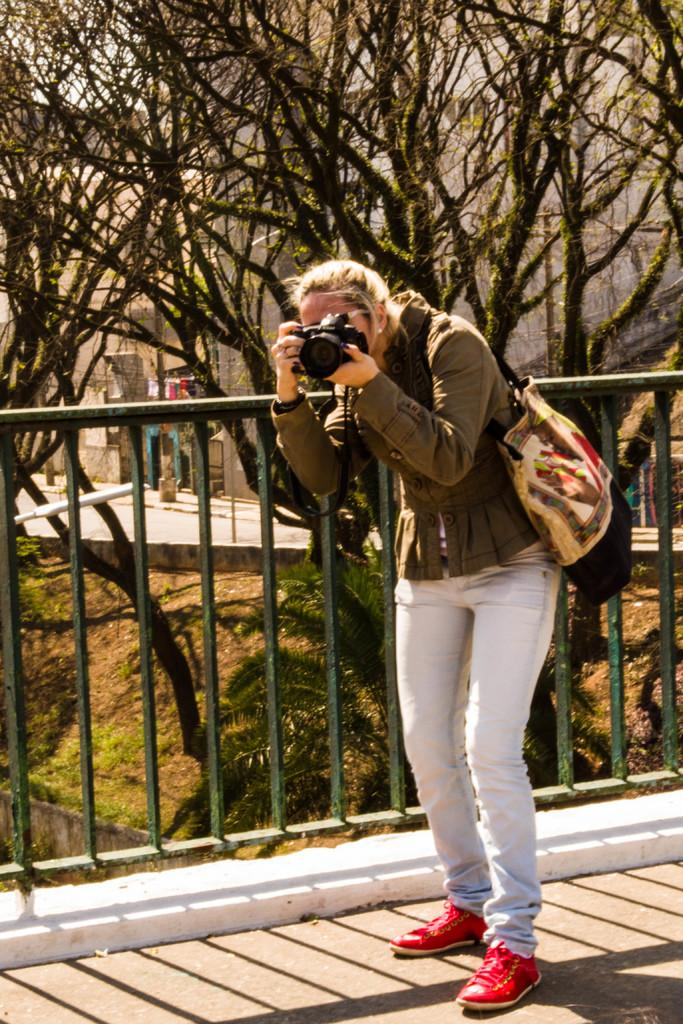Who is the main subject in the image? There is a woman in the image. What is the woman holding in her hands? The woman is holding a camera in her hands. What is the woman wearing on her body? The woman is wearing a bag. What can be seen in the background of the image? There are trees in the background of the image. Can you tell me what type of secretary the monkey is in the image? There is no monkey or secretary present in the image. 